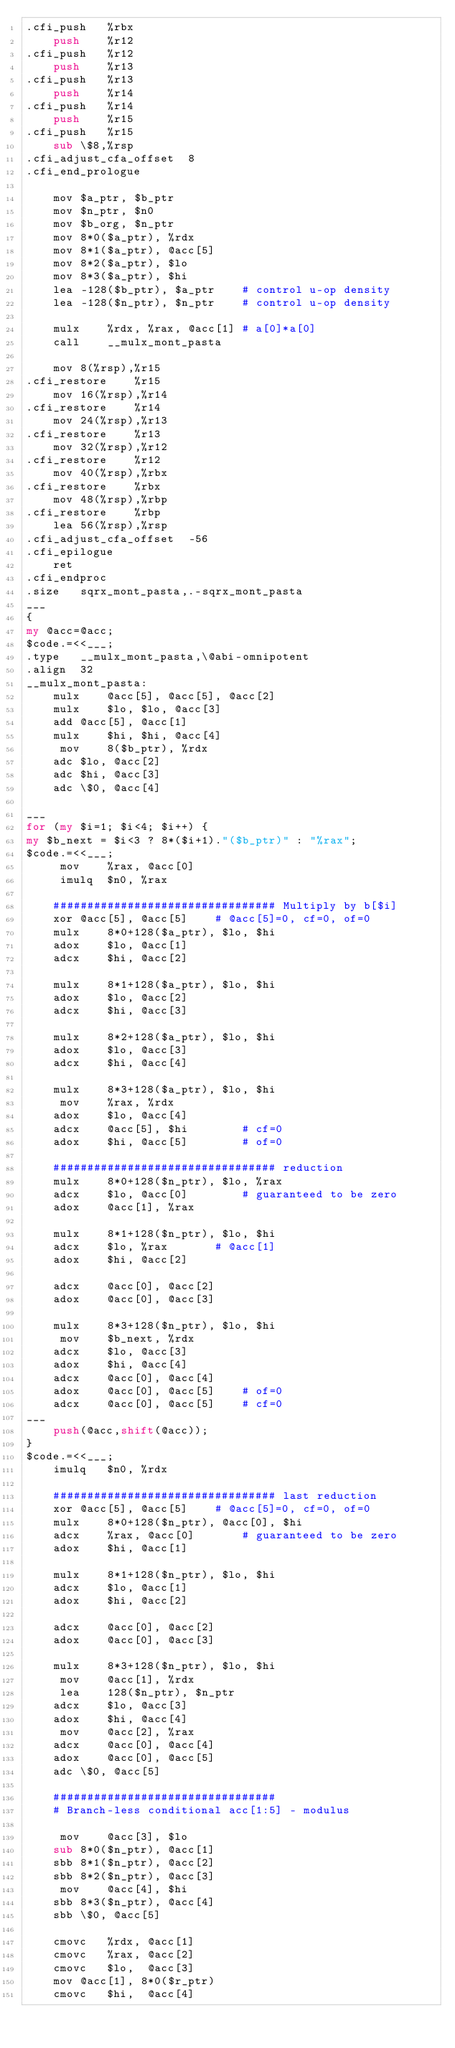<code> <loc_0><loc_0><loc_500><loc_500><_Perl_>.cfi_push	%rbx
	push	%r12
.cfi_push	%r12
	push	%r13
.cfi_push	%r13
	push	%r14
.cfi_push	%r14
	push	%r15
.cfi_push	%r15
	sub	\$8,%rsp
.cfi_adjust_cfa_offset	8
.cfi_end_prologue

	mov	$a_ptr, $b_ptr
	mov	$n_ptr, $n0
	mov	$b_org, $n_ptr
	mov	8*0($a_ptr), %rdx
	mov	8*1($a_ptr), @acc[5]
	mov	8*2($a_ptr), $lo
	mov	8*3($a_ptr), $hi
	lea	-128($b_ptr), $a_ptr	# control u-op density
	lea	-128($n_ptr), $n_ptr	# control u-op density

	mulx	%rdx, %rax, @acc[1]	# a[0]*a[0]
	call	__mulx_mont_pasta

	mov	8(%rsp),%r15
.cfi_restore	%r15
	mov	16(%rsp),%r14
.cfi_restore	%r14
	mov	24(%rsp),%r13
.cfi_restore	%r13
	mov	32(%rsp),%r12
.cfi_restore	%r12
	mov	40(%rsp),%rbx
.cfi_restore	%rbx
	mov	48(%rsp),%rbp
.cfi_restore	%rbp
	lea	56(%rsp),%rsp
.cfi_adjust_cfa_offset	-56
.cfi_epilogue
	ret
.cfi_endproc
.size	sqrx_mont_pasta,.-sqrx_mont_pasta
___
{
my @acc=@acc;
$code.=<<___;
.type	__mulx_mont_pasta,\@abi-omnipotent
.align	32
__mulx_mont_pasta:
	mulx	@acc[5], @acc[5], @acc[2]
	mulx	$lo, $lo, @acc[3]
	add	@acc[5], @acc[1]
	mulx	$hi, $hi, @acc[4]
	 mov	8($b_ptr), %rdx
	adc	$lo, @acc[2]
	adc	$hi, @acc[3]
	adc	\$0, @acc[4]

___
for (my $i=1; $i<4; $i++) {
my $b_next = $i<3 ? 8*($i+1)."($b_ptr)" : "%rax";
$code.=<<___;
	 mov	%rax, @acc[0]
	 imulq	$n0, %rax

	################################# Multiply by b[$i]
	xor	@acc[5], @acc[5]	# @acc[5]=0, cf=0, of=0
	mulx	8*0+128($a_ptr), $lo, $hi
	adox	$lo, @acc[1]
	adcx	$hi, @acc[2]

	mulx	8*1+128($a_ptr), $lo, $hi
	adox	$lo, @acc[2]
	adcx	$hi, @acc[3]

	mulx	8*2+128($a_ptr), $lo, $hi
	adox	$lo, @acc[3]
	adcx	$hi, @acc[4]

	mulx	8*3+128($a_ptr), $lo, $hi
	 mov	%rax, %rdx
	adox	$lo, @acc[4]
	adcx	@acc[5], $hi 		# cf=0
	adox	$hi, @acc[5]		# of=0

	################################# reduction
	mulx	8*0+128($n_ptr), $lo, %rax
	adcx	$lo, @acc[0]		# guaranteed to be zero
	adox	@acc[1], %rax

	mulx	8*1+128($n_ptr), $lo, $hi
	adcx	$lo, %rax		# @acc[1]
	adox	$hi, @acc[2]

	adcx	@acc[0], @acc[2]
	adox	@acc[0], @acc[3]

	mulx	8*3+128($n_ptr), $lo, $hi
	 mov	$b_next, %rdx
	adcx	$lo, @acc[3]
	adox	$hi, @acc[4]
	adcx	@acc[0], @acc[4]
	adox	@acc[0], @acc[5]	# of=0
	adcx	@acc[0], @acc[5]	# cf=0
___
    push(@acc,shift(@acc));
}
$code.=<<___;
	imulq	$n0, %rdx

	################################# last reduction
	xor	@acc[5], @acc[5]	# @acc[5]=0, cf=0, of=0
	mulx	8*0+128($n_ptr), @acc[0], $hi
	adcx	%rax, @acc[0]		# guaranteed to be zero
	adox	$hi, @acc[1]

	mulx	8*1+128($n_ptr), $lo, $hi
	adcx	$lo, @acc[1]
	adox	$hi, @acc[2]

	adcx	@acc[0], @acc[2]
	adox	@acc[0], @acc[3]

	mulx	8*3+128($n_ptr), $lo, $hi
	 mov	@acc[1], %rdx
	 lea	128($n_ptr), $n_ptr
	adcx	$lo, @acc[3]
	adox	$hi, @acc[4]
	 mov	@acc[2], %rax
	adcx	@acc[0], @acc[4]
	adox	@acc[0], @acc[5]
	adc	\$0, @acc[5]

	#################################
	# Branch-less conditional acc[1:5] - modulus

	 mov	@acc[3], $lo
	sub	8*0($n_ptr), @acc[1]
	sbb	8*1($n_ptr), @acc[2]
	sbb	8*2($n_ptr), @acc[3]
	 mov	@acc[4], $hi
	sbb	8*3($n_ptr), @acc[4]
	sbb	\$0, @acc[5]

	cmovc	%rdx, @acc[1]
	cmovc	%rax, @acc[2]
	cmovc	$lo,  @acc[3]
	mov	@acc[1], 8*0($r_ptr)
	cmovc	$hi,  @acc[4]</code> 